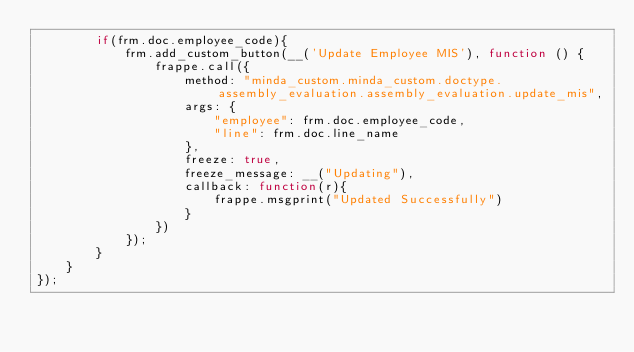Convert code to text. <code><loc_0><loc_0><loc_500><loc_500><_JavaScript_>        if(frm.doc.employee_code){
            frm.add_custom_button(__('Update Employee MIS'), function () {
                frappe.call({
                    method: "minda_custom.minda_custom.doctype.assembly_evaluation.assembly_evaluation.update_mis",
                    args: { 
                        "employee": frm.doc.employee_code,
                        "line": frm.doc.line_name
                    },
                    freeze: true,
                    freeze_message: __("Updating"),
                    callback: function(r){
                        frappe.msgprint("Updated Successfully")
                    }
                })
            });
        }
	}
});
</code> 